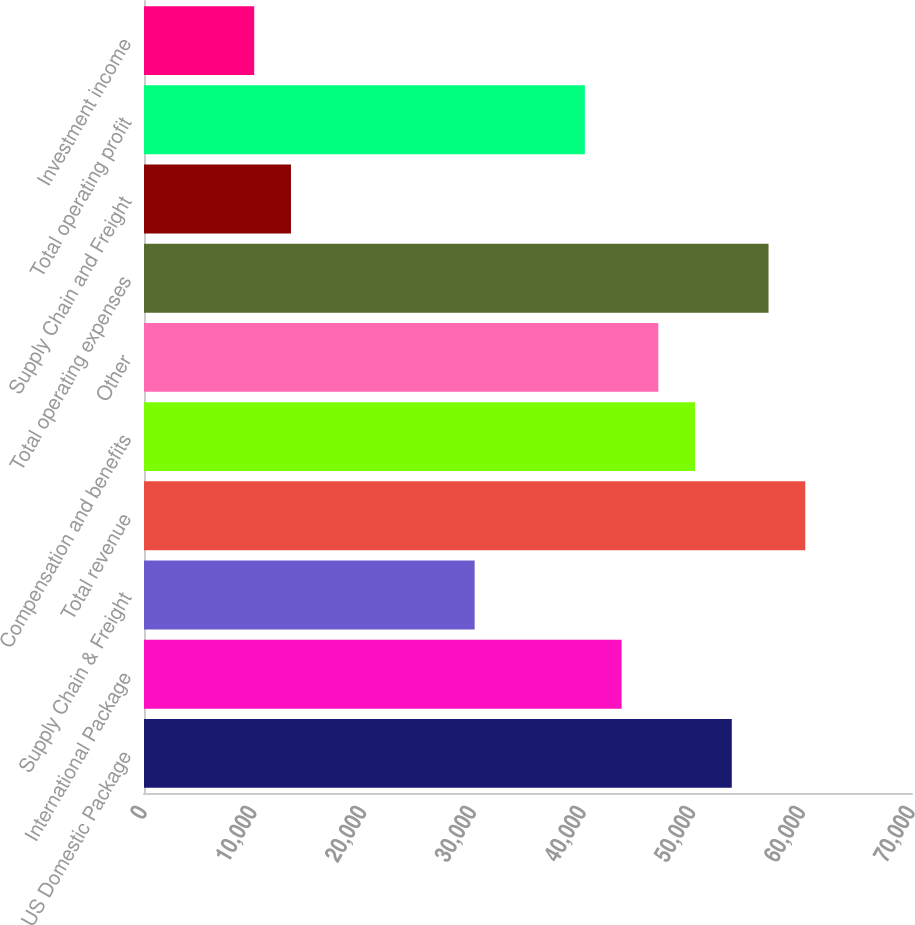Convert chart. <chart><loc_0><loc_0><loc_500><loc_500><bar_chart><fcel>US Domestic Package<fcel>International Package<fcel>Supply Chain & Freight<fcel>Total revenue<fcel>Compensation and benefits<fcel>Other<fcel>Total operating expenses<fcel>Supply Chain and Freight<fcel>Total operating profit<fcel>Investment income<nl><fcel>53575.5<fcel>43530.2<fcel>30136.6<fcel>60272.3<fcel>50227.1<fcel>46878.7<fcel>56923.9<fcel>13394.6<fcel>40181.8<fcel>10046.1<nl></chart> 